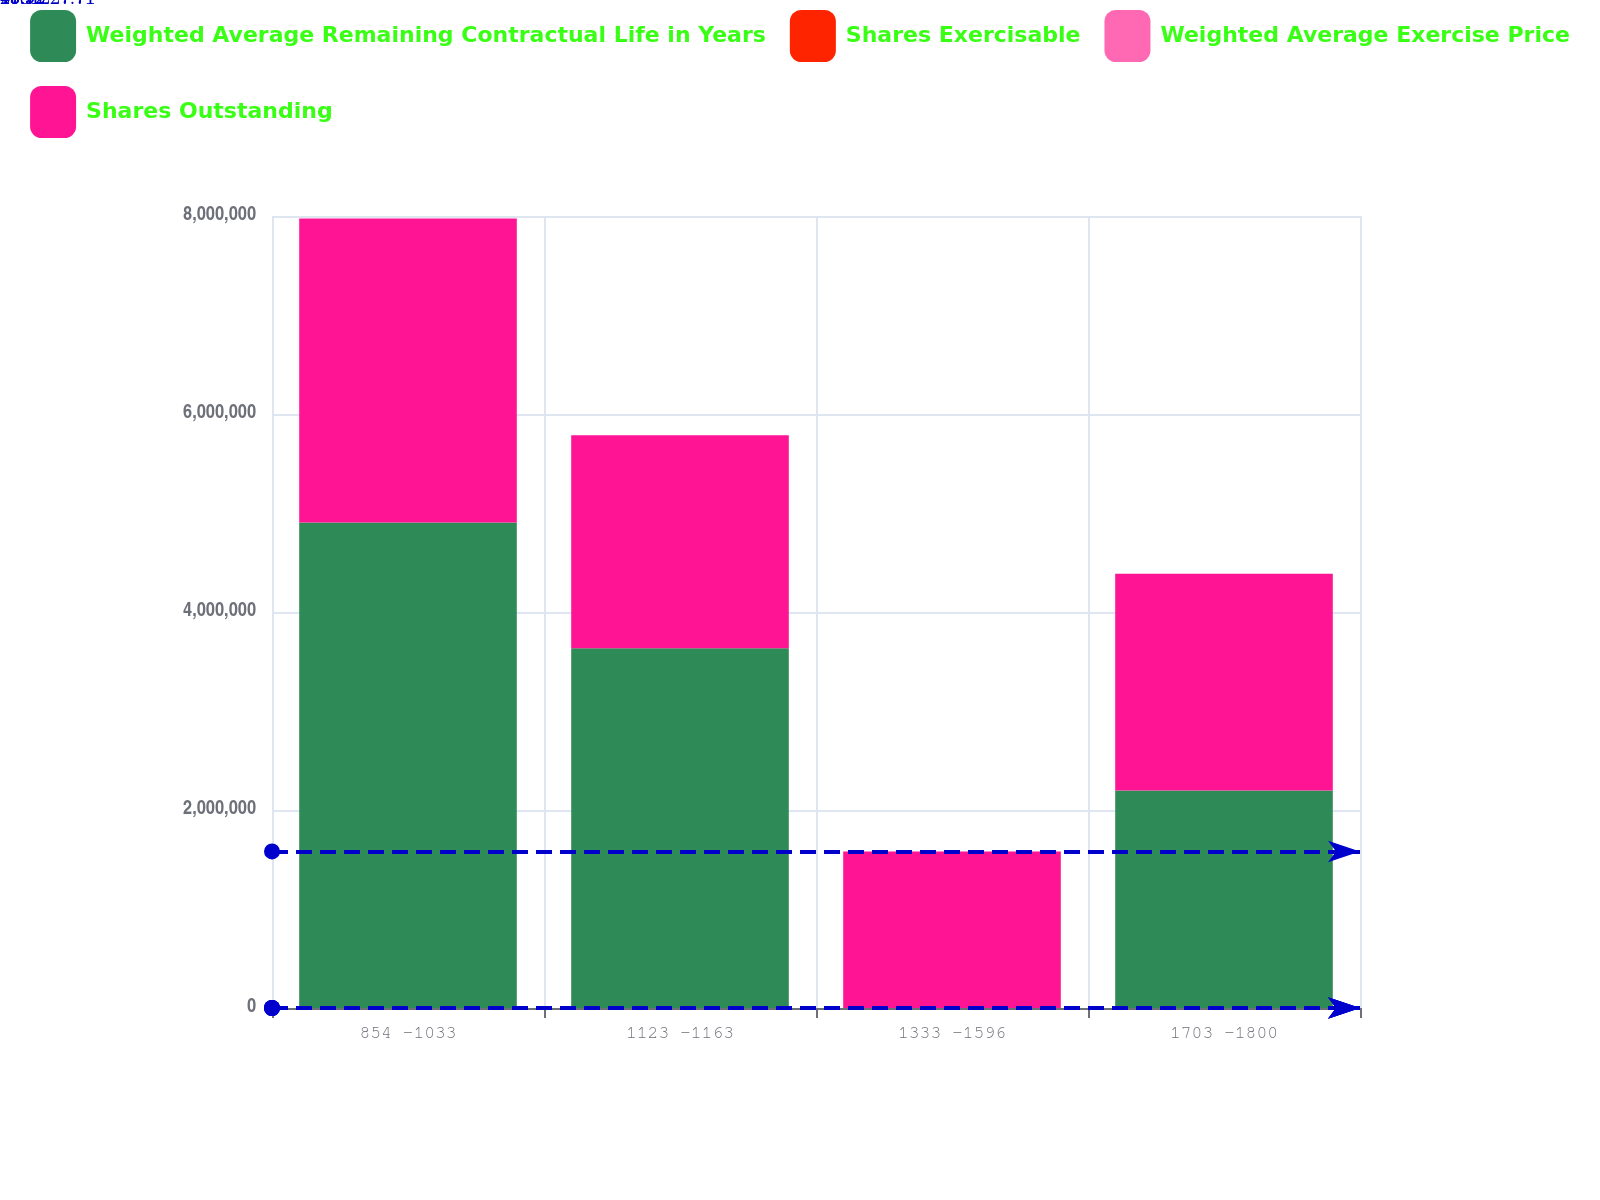Convert chart to OTSL. <chart><loc_0><loc_0><loc_500><loc_500><stacked_bar_chart><ecel><fcel>854 -1033<fcel>1123 -1163<fcel>1333 -1596<fcel>1703 -1800<nl><fcel>Weighted Average Remaining Contractual Life in Years<fcel>4.90481e+06<fcel>3.6348e+06<fcel>17.92<fcel>2.19795e+06<nl><fcel>Shares Exercisable<fcel>5.2<fcel>6.1<fcel>8<fcel>1.1<nl><fcel>Weighted Average Exercise Price<fcel>9.31<fcel>11.43<fcel>14.79<fcel>17.92<nl><fcel>Shares Outstanding<fcel>3.06884e+06<fcel>2.15071e+06<fcel>1.58119e+06<fcel>2.18895e+06<nl></chart> 